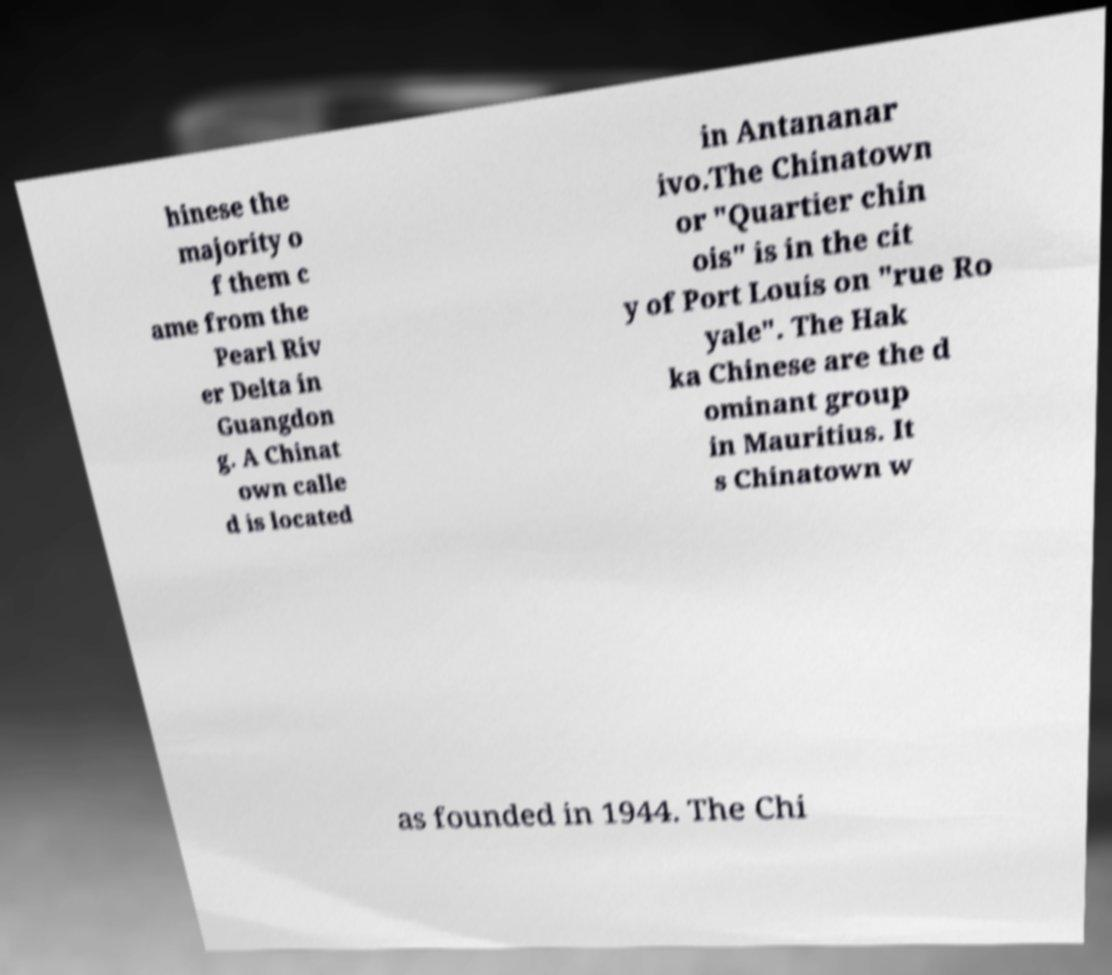Can you accurately transcribe the text from the provided image for me? hinese the majority o f them c ame from the Pearl Riv er Delta in Guangdon g. A Chinat own calle d is located in Antananar ivo.The Chinatown or "Quartier chin ois" is in the cit y of Port Louis on "rue Ro yale". The Hak ka Chinese are the d ominant group in Mauritius. It s Chinatown w as founded in 1944. The Chi 